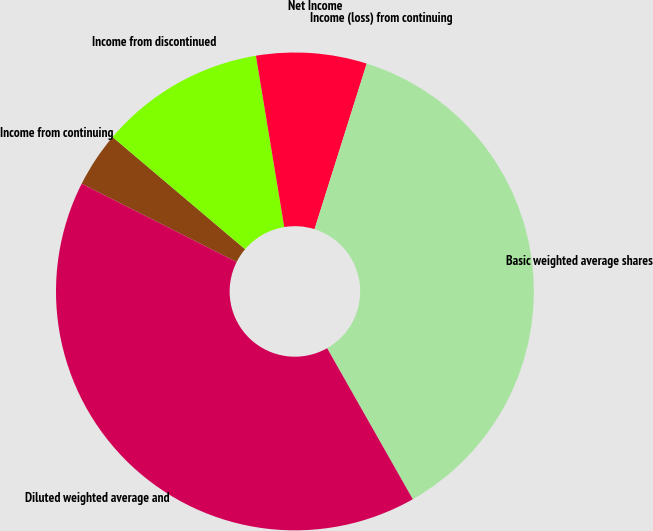Convert chart. <chart><loc_0><loc_0><loc_500><loc_500><pie_chart><fcel>Income from continuing<fcel>Income from discontinued<fcel>Net Income<fcel>Income (loss) from continuing<fcel>Basic weighted average shares<fcel>Diluted weighted average and<nl><fcel>3.74%<fcel>11.21%<fcel>7.47%<fcel>0.0%<fcel>36.93%<fcel>40.66%<nl></chart> 